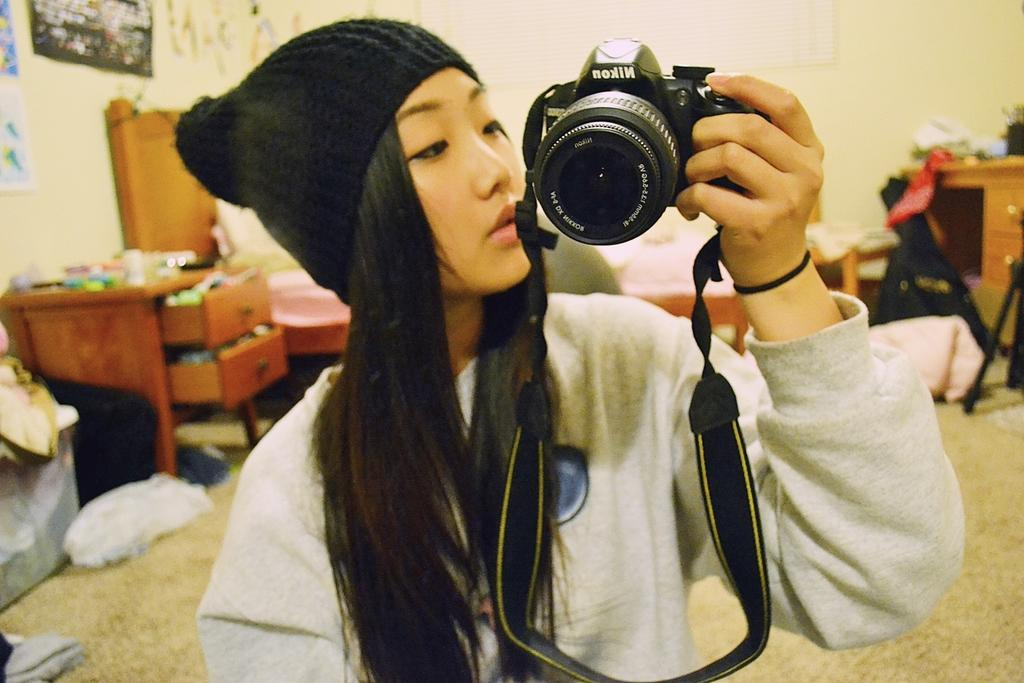What is one of the main features in the image? There is a wall in the image. What else can be seen on the wall? There is a paper and a photo frame in the image. Who is present in the image? A woman is standing in the front of the image. What is the woman holding? The woman is holding a camera. What type of cake is being served in the image? There is no cake present in the image. Can you tell me how many pencils are being used in the image? There are no pencils visible in the image. 